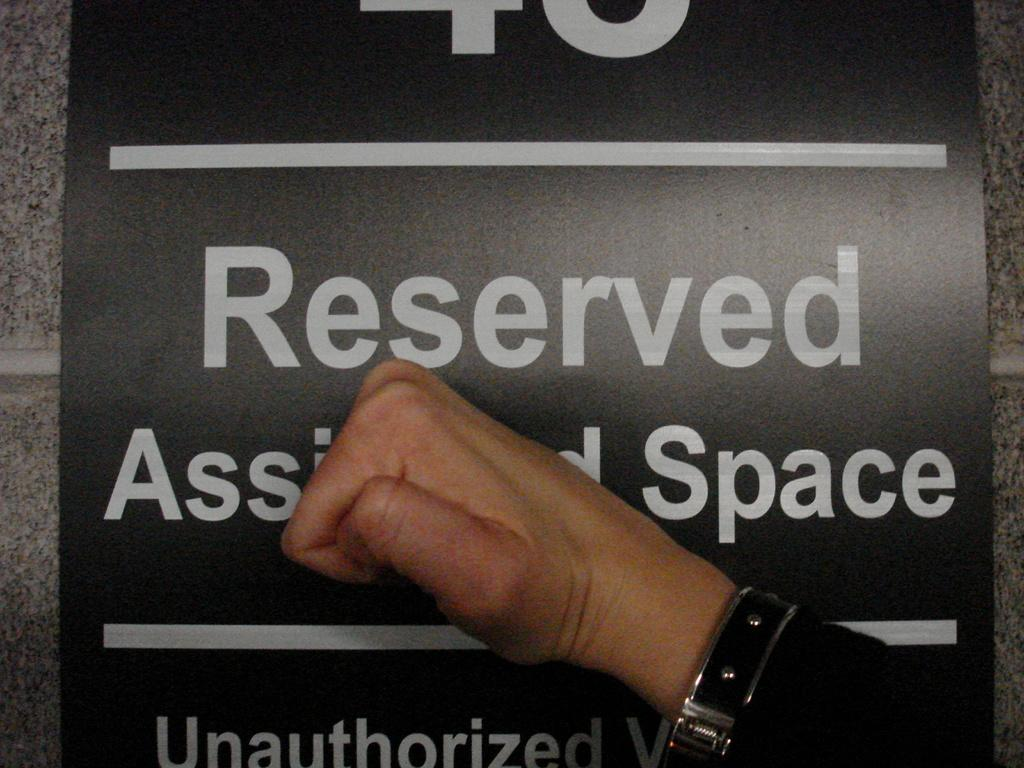<image>
Describe the image concisely. A fist knocking on a sign that says Reserved. 